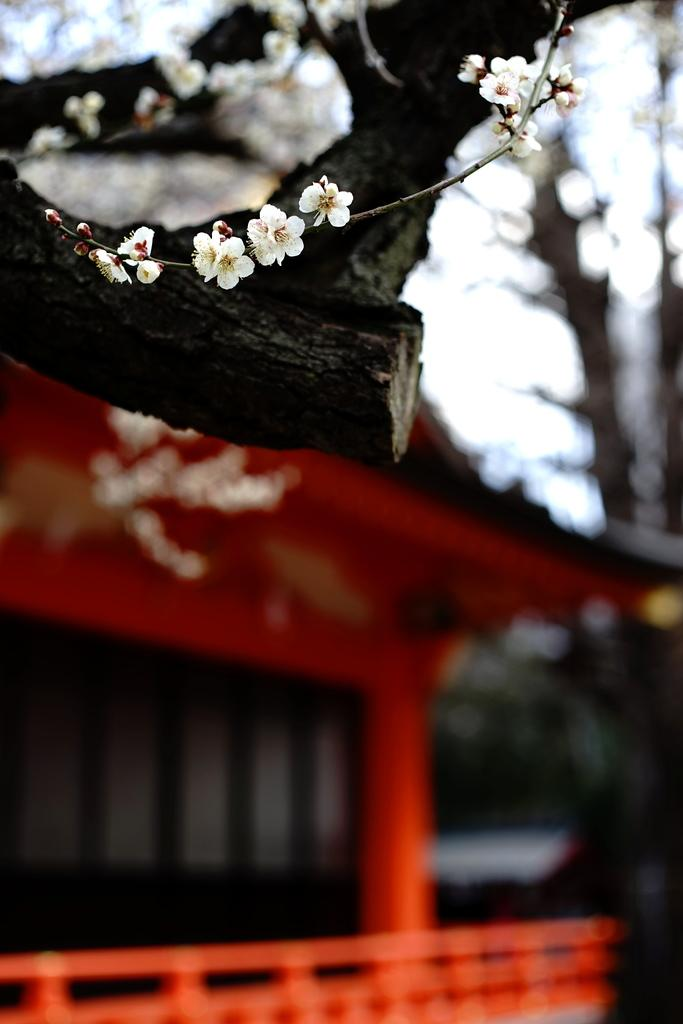What type of flowers are in the image? There are white flowers with stems in the image. What else can be seen in the image besides the flowers? There is a tree branch in the image. How would you describe the background of the image? The background has a blurred view, with a house, trees, and the sky visible. What type of gold fork is the monkey holding in the image? There is no monkey or gold fork present in the image. 